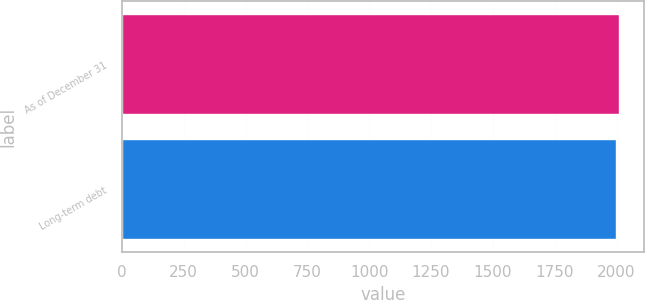Convert chart to OTSL. <chart><loc_0><loc_0><loc_500><loc_500><bar_chart><fcel>As of December 31<fcel>Long-term debt<nl><fcel>2009<fcel>1998<nl></chart> 